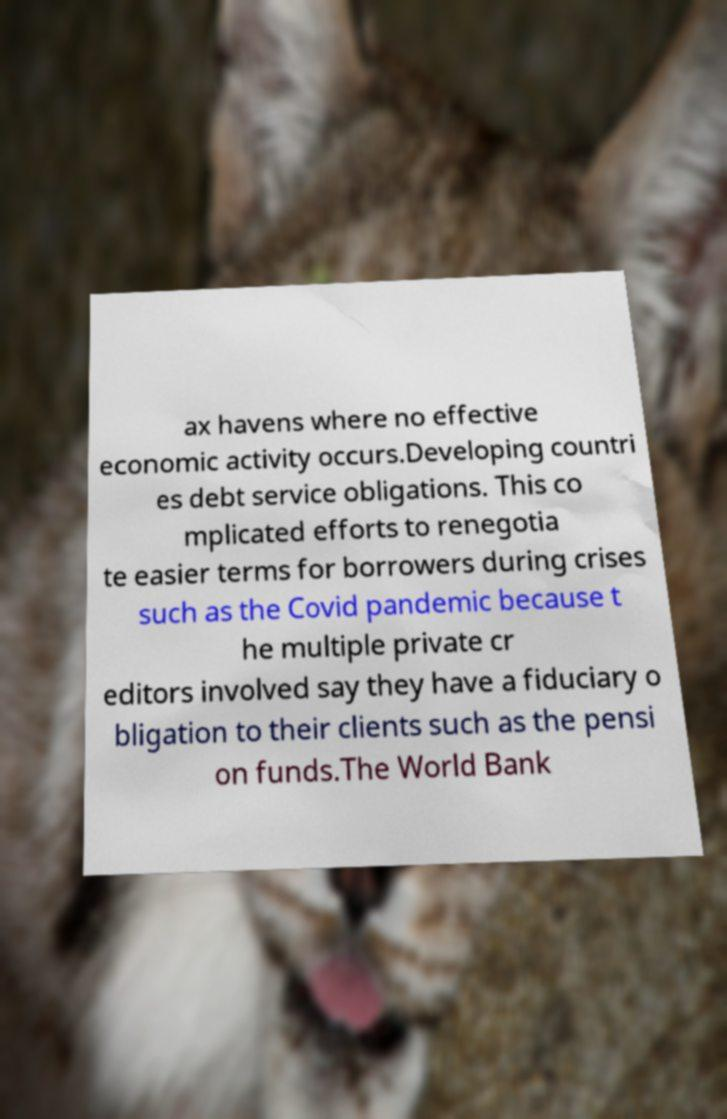I need the written content from this picture converted into text. Can you do that? ax havens where no effective economic activity occurs.Developing countri es debt service obligations. This co mplicated efforts to renegotia te easier terms for borrowers during crises such as the Covid pandemic because t he multiple private cr editors involved say they have a fiduciary o bligation to their clients such as the pensi on funds.The World Bank 